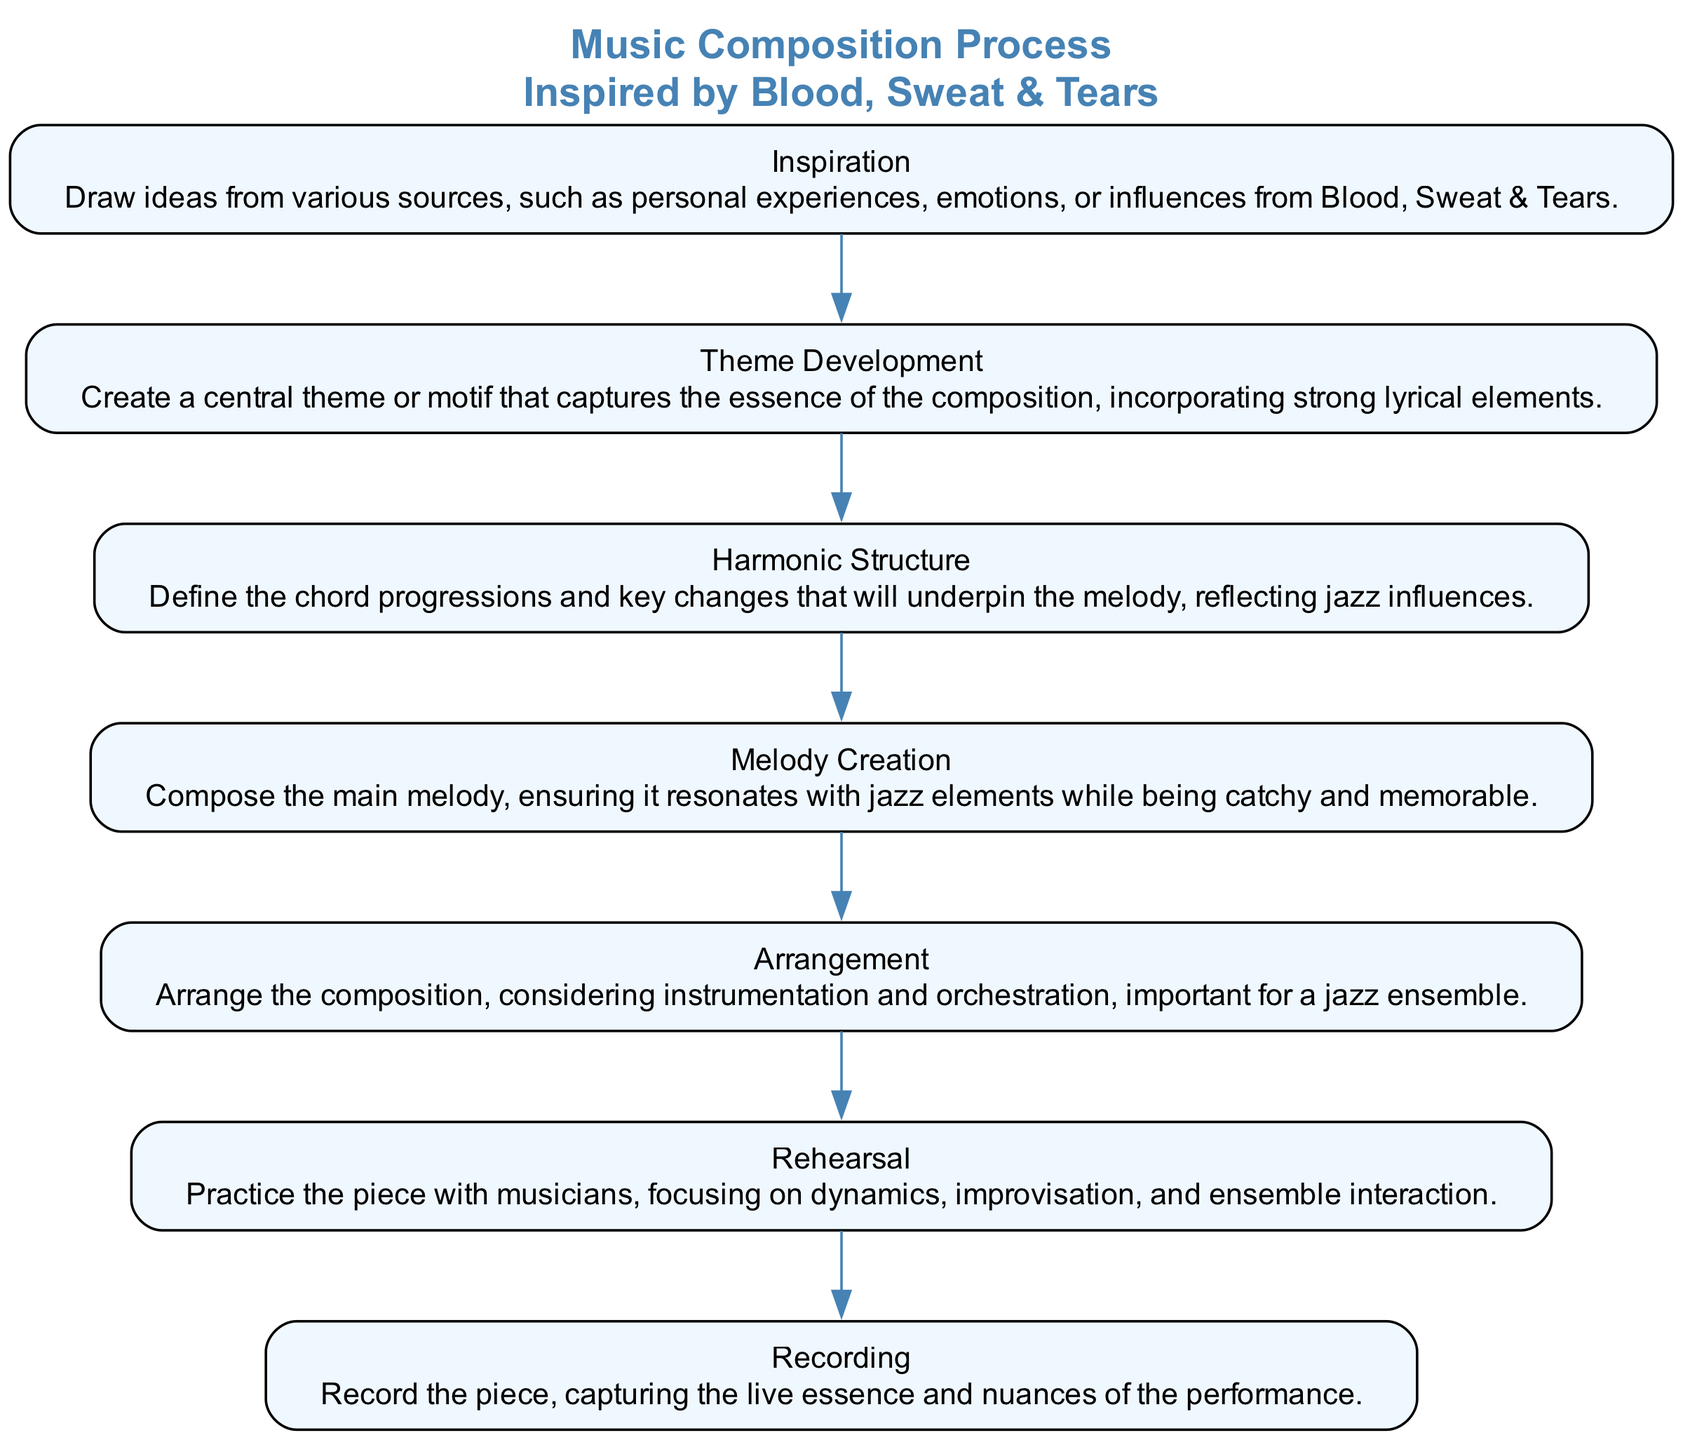What is the first step in the music composition process? The diagram shows "Inspiration" as the first element in the flow chart, indicating that it is the starting point of the music composition process.
Answer: Inspiration How many elements are in the music composition process? By counting the number of elements listed in the diagram, we see that there are a total of seven nodes, representing each step in the process.
Answer: 7 What is the last step in the music composition process? The flow chart indicates that the last step is "Recording," which is the final task after rehearsal and arrangement.
Answer: Recording What step comes after "Melody Creation"? Looking at the sequence of nodes in the diagram, "Arrangement" directly follows "Melody Creation," showing the order of steps in the music composition process.
Answer: Arrangement Which step focuses on playing with musicians? The diagram shows "Rehearsal" as the step where the piece is practiced with musicians, highlighting its importance in the overall process.
Answer: Rehearsal What is the relationship between "Theme Development" and "Harmonic Structure"? In the diagram, "Theme Development" is followed by "Harmonic Structure," indicating that after developing the theme, the next logical step is to define the harmonic aspects that support it.
Answer: Sequential connection How does "Inspiration" influence the "Theme Development"? The diagram indicates that "Inspiration" leads into "Theme Development," implying that the ideas gathered from inspiration contribute to the creation of the central theme or motif in composition.
Answer: Influences the theme What should be considered in the "Arrangement" step? The description in the diagram specifies that arrangement focuses on instrumentation and orchestration, crucial elements in crafting a jazz ensemble's sound.
Answer: Instrumentation and orchestration What is the primary focus during "Recording"? The flow chart states that the emphasis during "Recording" is on capturing the live essence and nuances of the performance, which is vital in the final production of the piece.
Answer: Capturing live essence 